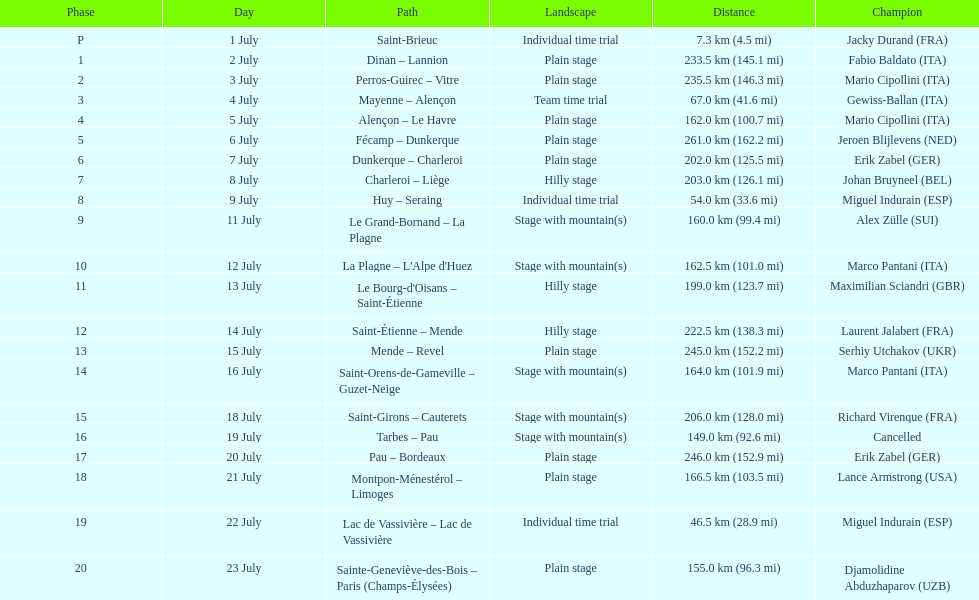Which routes were at least 100 km? Dinan - Lannion, Perros-Guirec - Vitre, Alençon - Le Havre, Fécamp - Dunkerque, Dunkerque - Charleroi, Charleroi - Liège, Le Grand-Bornand - La Plagne, La Plagne - L'Alpe d'Huez, Le Bourg-d'Oisans - Saint-Étienne, Saint-Étienne - Mende, Mende - Revel, Saint-Orens-de-Gameville - Guzet-Neige, Saint-Girons - Cauterets, Tarbes - Pau, Pau - Bordeaux, Montpon-Ménestérol - Limoges, Sainte-Geneviève-des-Bois - Paris (Champs-Élysées). 